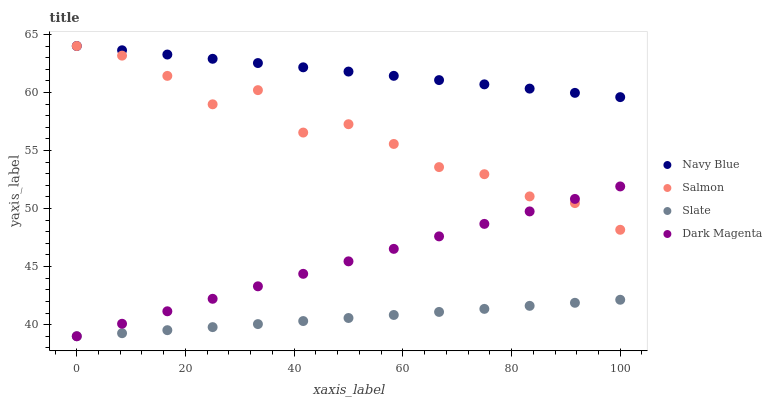Does Slate have the minimum area under the curve?
Answer yes or no. Yes. Does Navy Blue have the maximum area under the curve?
Answer yes or no. Yes. Does Salmon have the minimum area under the curve?
Answer yes or no. No. Does Salmon have the maximum area under the curve?
Answer yes or no. No. Is Navy Blue the smoothest?
Answer yes or no. Yes. Is Salmon the roughest?
Answer yes or no. Yes. Is Slate the smoothest?
Answer yes or no. No. Is Slate the roughest?
Answer yes or no. No. Does Slate have the lowest value?
Answer yes or no. Yes. Does Salmon have the lowest value?
Answer yes or no. No. Does Salmon have the highest value?
Answer yes or no. Yes. Does Slate have the highest value?
Answer yes or no. No. Is Slate less than Navy Blue?
Answer yes or no. Yes. Is Navy Blue greater than Slate?
Answer yes or no. Yes. Does Navy Blue intersect Salmon?
Answer yes or no. Yes. Is Navy Blue less than Salmon?
Answer yes or no. No. Is Navy Blue greater than Salmon?
Answer yes or no. No. Does Slate intersect Navy Blue?
Answer yes or no. No. 